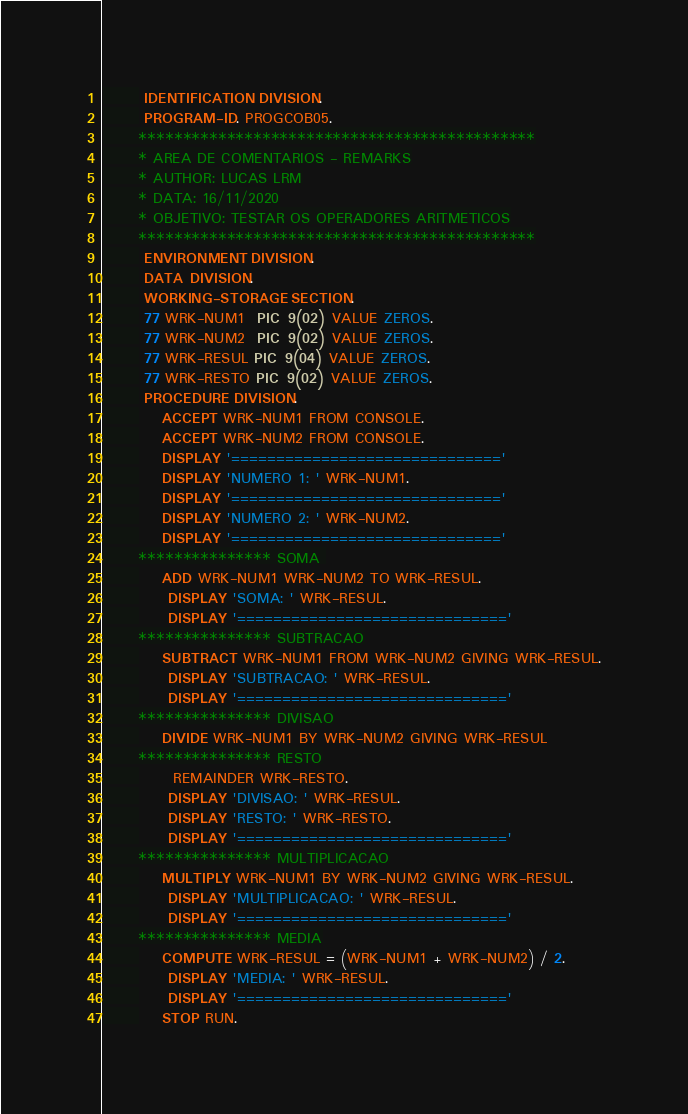Convert code to text. <code><loc_0><loc_0><loc_500><loc_500><_COBOL_>       IDENTIFICATION DIVISION.
       PROGRAM-ID. PROGCOB05.
      *********************************************
      * AREA DE COMENTARIOS - REMARKS
      * AUTHOR: LUCAS LRM
      * DATA: 16/11/2020
      * OBJETIVO: TESTAR OS OPERADORES ARITMETICOS
      *********************************************
       ENVIRONMENT DIVISION.
       DATA DIVISION.
       WORKING-STORAGE SECTION.
       77 WRK-NUM1  PIC 9(02)  VALUE ZEROS.
       77 WRK-NUM2  PIC 9(02)  VALUE ZEROS.
       77 WRK-RESUL PIC 9(04)  VALUE ZEROS.
       77 WRK-RESTO PIC 9(02)  VALUE ZEROS.
       PROCEDURE DIVISION.
          ACCEPT WRK-NUM1 FROM CONSOLE.
          ACCEPT WRK-NUM2 FROM CONSOLE.
          DISPLAY '=============================='
          DISPLAY 'NUMERO 1: ' WRK-NUM1.
          DISPLAY '=============================='
          DISPLAY 'NUMERO 2: ' WRK-NUM2.
          DISPLAY '=============================='
      *************** SOMA 
          ADD WRK-NUM1 WRK-NUM2 TO WRK-RESUL.
           DISPLAY 'SOMA: ' WRK-RESUL.
           DISPLAY '=============================='
      *************** SUBTRACAO
          SUBTRACT WRK-NUM1 FROM WRK-NUM2 GIVING WRK-RESUL.
           DISPLAY 'SUBTRACAO: ' WRK-RESUL.
           DISPLAY '=============================='
      *************** DIVISAO
          DIVIDE WRK-NUM1 BY WRK-NUM2 GIVING WRK-RESUL
      *************** RESTO
      	  REMAINDER WRK-RESTO.
           DISPLAY 'DIVISAO: ' WRK-RESUL.
           DISPLAY 'RESTO: ' WRK-RESTO.
           DISPLAY '=============================='
      *************** MULTIPLICACAO
          MULTIPLY WRK-NUM1 BY WRK-NUM2 GIVING WRK-RESUL.
           DISPLAY 'MULTIPLICACAO: ' WRK-RESUL.
           DISPLAY '=============================='
      *************** MEDIA
          COMPUTE WRK-RESUL = (WRK-NUM1 + WRK-NUM2) / 2.
           DISPLAY 'MEDIA: ' WRK-RESUL.
           DISPLAY '=============================='
          STOP RUN.
</code> 